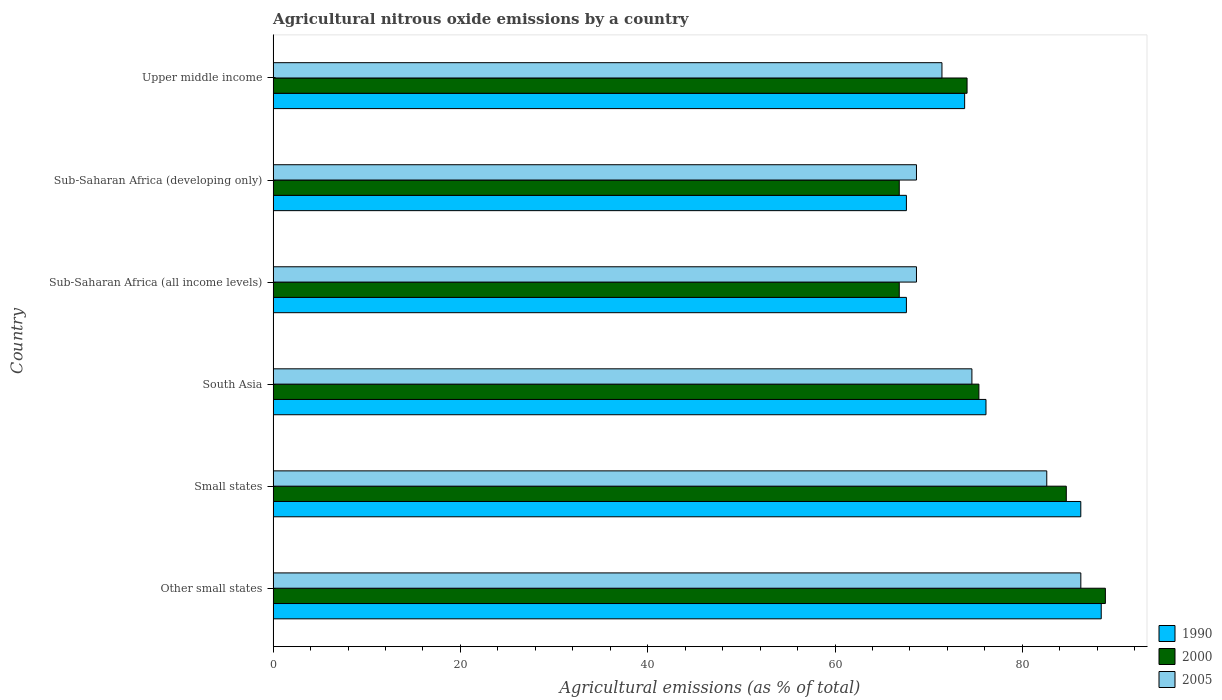How many different coloured bars are there?
Provide a succinct answer. 3. Are the number of bars per tick equal to the number of legend labels?
Your answer should be compact. Yes. How many bars are there on the 4th tick from the bottom?
Your answer should be very brief. 3. What is the label of the 2nd group of bars from the top?
Your response must be concise. Sub-Saharan Africa (developing only). In how many cases, is the number of bars for a given country not equal to the number of legend labels?
Ensure brevity in your answer.  0. What is the amount of agricultural nitrous oxide emitted in 1990 in Sub-Saharan Africa (all income levels)?
Keep it short and to the point. 67.62. Across all countries, what is the maximum amount of agricultural nitrous oxide emitted in 1990?
Keep it short and to the point. 88.42. Across all countries, what is the minimum amount of agricultural nitrous oxide emitted in 2005?
Your answer should be compact. 68.7. In which country was the amount of agricultural nitrous oxide emitted in 1990 maximum?
Ensure brevity in your answer.  Other small states. In which country was the amount of agricultural nitrous oxide emitted in 2000 minimum?
Keep it short and to the point. Sub-Saharan Africa (all income levels). What is the total amount of agricultural nitrous oxide emitted in 2005 in the graph?
Ensure brevity in your answer.  452.28. What is the difference between the amount of agricultural nitrous oxide emitted in 1990 in Other small states and that in Sub-Saharan Africa (developing only)?
Give a very brief answer. 20.8. What is the difference between the amount of agricultural nitrous oxide emitted in 2005 in Upper middle income and the amount of agricultural nitrous oxide emitted in 2000 in Small states?
Provide a succinct answer. -13.28. What is the average amount of agricultural nitrous oxide emitted in 2000 per country?
Make the answer very short. 76.12. What is the difference between the amount of agricultural nitrous oxide emitted in 1990 and amount of agricultural nitrous oxide emitted in 2000 in Sub-Saharan Africa (developing only)?
Your answer should be compact. 0.76. In how many countries, is the amount of agricultural nitrous oxide emitted in 1990 greater than 64 %?
Make the answer very short. 6. What is the ratio of the amount of agricultural nitrous oxide emitted in 2005 in South Asia to that in Sub-Saharan Africa (all income levels)?
Provide a short and direct response. 1.09. Is the amount of agricultural nitrous oxide emitted in 2005 in South Asia less than that in Sub-Saharan Africa (all income levels)?
Make the answer very short. No. Is the difference between the amount of agricultural nitrous oxide emitted in 1990 in Small states and Sub-Saharan Africa (all income levels) greater than the difference between the amount of agricultural nitrous oxide emitted in 2000 in Small states and Sub-Saharan Africa (all income levels)?
Keep it short and to the point. Yes. What is the difference between the highest and the second highest amount of agricultural nitrous oxide emitted in 1990?
Make the answer very short. 2.18. What is the difference between the highest and the lowest amount of agricultural nitrous oxide emitted in 2005?
Your answer should be very brief. 17.55. In how many countries, is the amount of agricultural nitrous oxide emitted in 2000 greater than the average amount of agricultural nitrous oxide emitted in 2000 taken over all countries?
Your answer should be compact. 2. How many countries are there in the graph?
Provide a short and direct response. 6. Are the values on the major ticks of X-axis written in scientific E-notation?
Your answer should be very brief. No. Where does the legend appear in the graph?
Keep it short and to the point. Bottom right. How many legend labels are there?
Your answer should be compact. 3. What is the title of the graph?
Give a very brief answer. Agricultural nitrous oxide emissions by a country. What is the label or title of the X-axis?
Offer a very short reply. Agricultural emissions (as % of total). What is the label or title of the Y-axis?
Offer a terse response. Country. What is the Agricultural emissions (as % of total) of 1990 in Other small states?
Ensure brevity in your answer.  88.42. What is the Agricultural emissions (as % of total) in 2000 in Other small states?
Provide a succinct answer. 88.87. What is the Agricultural emissions (as % of total) in 2005 in Other small states?
Your answer should be very brief. 86.25. What is the Agricultural emissions (as % of total) in 1990 in Small states?
Provide a succinct answer. 86.24. What is the Agricultural emissions (as % of total) in 2000 in Small states?
Your answer should be very brief. 84.69. What is the Agricultural emissions (as % of total) in 2005 in Small states?
Offer a very short reply. 82.61. What is the Agricultural emissions (as % of total) of 1990 in South Asia?
Your answer should be compact. 76.12. What is the Agricultural emissions (as % of total) in 2000 in South Asia?
Keep it short and to the point. 75.36. What is the Agricultural emissions (as % of total) in 2005 in South Asia?
Make the answer very short. 74.62. What is the Agricultural emissions (as % of total) in 1990 in Sub-Saharan Africa (all income levels)?
Offer a very short reply. 67.62. What is the Agricultural emissions (as % of total) of 2000 in Sub-Saharan Africa (all income levels)?
Offer a very short reply. 66.86. What is the Agricultural emissions (as % of total) of 2005 in Sub-Saharan Africa (all income levels)?
Keep it short and to the point. 68.7. What is the Agricultural emissions (as % of total) of 1990 in Sub-Saharan Africa (developing only)?
Your response must be concise. 67.62. What is the Agricultural emissions (as % of total) of 2000 in Sub-Saharan Africa (developing only)?
Ensure brevity in your answer.  66.86. What is the Agricultural emissions (as % of total) in 2005 in Sub-Saharan Africa (developing only)?
Provide a short and direct response. 68.7. What is the Agricultural emissions (as % of total) of 1990 in Upper middle income?
Offer a terse response. 73.84. What is the Agricultural emissions (as % of total) of 2000 in Upper middle income?
Provide a short and direct response. 74.1. What is the Agricultural emissions (as % of total) of 2005 in Upper middle income?
Your answer should be compact. 71.42. Across all countries, what is the maximum Agricultural emissions (as % of total) of 1990?
Your response must be concise. 88.42. Across all countries, what is the maximum Agricultural emissions (as % of total) of 2000?
Offer a terse response. 88.87. Across all countries, what is the maximum Agricultural emissions (as % of total) of 2005?
Give a very brief answer. 86.25. Across all countries, what is the minimum Agricultural emissions (as % of total) in 1990?
Keep it short and to the point. 67.62. Across all countries, what is the minimum Agricultural emissions (as % of total) in 2000?
Your response must be concise. 66.86. Across all countries, what is the minimum Agricultural emissions (as % of total) in 2005?
Your answer should be very brief. 68.7. What is the total Agricultural emissions (as % of total) in 1990 in the graph?
Give a very brief answer. 459.87. What is the total Agricultural emissions (as % of total) of 2000 in the graph?
Your response must be concise. 456.74. What is the total Agricultural emissions (as % of total) of 2005 in the graph?
Make the answer very short. 452.28. What is the difference between the Agricultural emissions (as % of total) of 1990 in Other small states and that in Small states?
Your response must be concise. 2.18. What is the difference between the Agricultural emissions (as % of total) in 2000 in Other small states and that in Small states?
Your response must be concise. 4.17. What is the difference between the Agricultural emissions (as % of total) in 2005 in Other small states and that in Small states?
Your answer should be compact. 3.64. What is the difference between the Agricultural emissions (as % of total) in 1990 in Other small states and that in South Asia?
Ensure brevity in your answer.  12.31. What is the difference between the Agricultural emissions (as % of total) in 2000 in Other small states and that in South Asia?
Offer a very short reply. 13.51. What is the difference between the Agricultural emissions (as % of total) in 2005 in Other small states and that in South Asia?
Provide a short and direct response. 11.63. What is the difference between the Agricultural emissions (as % of total) of 1990 in Other small states and that in Sub-Saharan Africa (all income levels)?
Offer a very short reply. 20.8. What is the difference between the Agricultural emissions (as % of total) in 2000 in Other small states and that in Sub-Saharan Africa (all income levels)?
Make the answer very short. 22.01. What is the difference between the Agricultural emissions (as % of total) of 2005 in Other small states and that in Sub-Saharan Africa (all income levels)?
Ensure brevity in your answer.  17.55. What is the difference between the Agricultural emissions (as % of total) of 1990 in Other small states and that in Sub-Saharan Africa (developing only)?
Make the answer very short. 20.8. What is the difference between the Agricultural emissions (as % of total) of 2000 in Other small states and that in Sub-Saharan Africa (developing only)?
Your response must be concise. 22.01. What is the difference between the Agricultural emissions (as % of total) in 2005 in Other small states and that in Sub-Saharan Africa (developing only)?
Make the answer very short. 17.55. What is the difference between the Agricultural emissions (as % of total) in 1990 in Other small states and that in Upper middle income?
Offer a very short reply. 14.59. What is the difference between the Agricultural emissions (as % of total) in 2000 in Other small states and that in Upper middle income?
Ensure brevity in your answer.  14.77. What is the difference between the Agricultural emissions (as % of total) of 2005 in Other small states and that in Upper middle income?
Offer a very short reply. 14.83. What is the difference between the Agricultural emissions (as % of total) in 1990 in Small states and that in South Asia?
Your answer should be compact. 10.12. What is the difference between the Agricultural emissions (as % of total) of 2000 in Small states and that in South Asia?
Ensure brevity in your answer.  9.33. What is the difference between the Agricultural emissions (as % of total) in 2005 in Small states and that in South Asia?
Offer a very short reply. 7.99. What is the difference between the Agricultural emissions (as % of total) in 1990 in Small states and that in Sub-Saharan Africa (all income levels)?
Your response must be concise. 18.62. What is the difference between the Agricultural emissions (as % of total) in 2000 in Small states and that in Sub-Saharan Africa (all income levels)?
Ensure brevity in your answer.  17.84. What is the difference between the Agricultural emissions (as % of total) in 2005 in Small states and that in Sub-Saharan Africa (all income levels)?
Your response must be concise. 13.91. What is the difference between the Agricultural emissions (as % of total) of 1990 in Small states and that in Sub-Saharan Africa (developing only)?
Provide a succinct answer. 18.62. What is the difference between the Agricultural emissions (as % of total) of 2000 in Small states and that in Sub-Saharan Africa (developing only)?
Make the answer very short. 17.84. What is the difference between the Agricultural emissions (as % of total) of 2005 in Small states and that in Sub-Saharan Africa (developing only)?
Your answer should be compact. 13.91. What is the difference between the Agricultural emissions (as % of total) of 1990 in Small states and that in Upper middle income?
Keep it short and to the point. 12.4. What is the difference between the Agricultural emissions (as % of total) in 2000 in Small states and that in Upper middle income?
Make the answer very short. 10.6. What is the difference between the Agricultural emissions (as % of total) of 2005 in Small states and that in Upper middle income?
Give a very brief answer. 11.19. What is the difference between the Agricultural emissions (as % of total) in 1990 in South Asia and that in Sub-Saharan Africa (all income levels)?
Ensure brevity in your answer.  8.5. What is the difference between the Agricultural emissions (as % of total) of 2000 in South Asia and that in Sub-Saharan Africa (all income levels)?
Keep it short and to the point. 8.5. What is the difference between the Agricultural emissions (as % of total) of 2005 in South Asia and that in Sub-Saharan Africa (all income levels)?
Provide a succinct answer. 5.92. What is the difference between the Agricultural emissions (as % of total) in 1990 in South Asia and that in Sub-Saharan Africa (developing only)?
Your answer should be compact. 8.5. What is the difference between the Agricultural emissions (as % of total) of 2000 in South Asia and that in Sub-Saharan Africa (developing only)?
Your response must be concise. 8.5. What is the difference between the Agricultural emissions (as % of total) of 2005 in South Asia and that in Sub-Saharan Africa (developing only)?
Ensure brevity in your answer.  5.92. What is the difference between the Agricultural emissions (as % of total) in 1990 in South Asia and that in Upper middle income?
Give a very brief answer. 2.28. What is the difference between the Agricultural emissions (as % of total) in 2000 in South Asia and that in Upper middle income?
Your response must be concise. 1.26. What is the difference between the Agricultural emissions (as % of total) in 2005 in South Asia and that in Upper middle income?
Offer a terse response. 3.2. What is the difference between the Agricultural emissions (as % of total) in 1990 in Sub-Saharan Africa (all income levels) and that in Sub-Saharan Africa (developing only)?
Your response must be concise. 0. What is the difference between the Agricultural emissions (as % of total) of 2000 in Sub-Saharan Africa (all income levels) and that in Sub-Saharan Africa (developing only)?
Ensure brevity in your answer.  0. What is the difference between the Agricultural emissions (as % of total) in 1990 in Sub-Saharan Africa (all income levels) and that in Upper middle income?
Give a very brief answer. -6.22. What is the difference between the Agricultural emissions (as % of total) in 2000 in Sub-Saharan Africa (all income levels) and that in Upper middle income?
Offer a terse response. -7.24. What is the difference between the Agricultural emissions (as % of total) in 2005 in Sub-Saharan Africa (all income levels) and that in Upper middle income?
Ensure brevity in your answer.  -2.72. What is the difference between the Agricultural emissions (as % of total) in 1990 in Sub-Saharan Africa (developing only) and that in Upper middle income?
Give a very brief answer. -6.22. What is the difference between the Agricultural emissions (as % of total) in 2000 in Sub-Saharan Africa (developing only) and that in Upper middle income?
Keep it short and to the point. -7.24. What is the difference between the Agricultural emissions (as % of total) of 2005 in Sub-Saharan Africa (developing only) and that in Upper middle income?
Your answer should be compact. -2.72. What is the difference between the Agricultural emissions (as % of total) in 1990 in Other small states and the Agricultural emissions (as % of total) in 2000 in Small states?
Offer a very short reply. 3.73. What is the difference between the Agricultural emissions (as % of total) in 1990 in Other small states and the Agricultural emissions (as % of total) in 2005 in Small states?
Your response must be concise. 5.82. What is the difference between the Agricultural emissions (as % of total) of 2000 in Other small states and the Agricultural emissions (as % of total) of 2005 in Small states?
Your response must be concise. 6.26. What is the difference between the Agricultural emissions (as % of total) of 1990 in Other small states and the Agricultural emissions (as % of total) of 2000 in South Asia?
Make the answer very short. 13.06. What is the difference between the Agricultural emissions (as % of total) in 1990 in Other small states and the Agricultural emissions (as % of total) in 2005 in South Asia?
Provide a succinct answer. 13.81. What is the difference between the Agricultural emissions (as % of total) in 2000 in Other small states and the Agricultural emissions (as % of total) in 2005 in South Asia?
Your response must be concise. 14.25. What is the difference between the Agricultural emissions (as % of total) of 1990 in Other small states and the Agricultural emissions (as % of total) of 2000 in Sub-Saharan Africa (all income levels)?
Give a very brief answer. 21.57. What is the difference between the Agricultural emissions (as % of total) in 1990 in Other small states and the Agricultural emissions (as % of total) in 2005 in Sub-Saharan Africa (all income levels)?
Provide a short and direct response. 19.73. What is the difference between the Agricultural emissions (as % of total) in 2000 in Other small states and the Agricultural emissions (as % of total) in 2005 in Sub-Saharan Africa (all income levels)?
Your answer should be compact. 20.17. What is the difference between the Agricultural emissions (as % of total) in 1990 in Other small states and the Agricultural emissions (as % of total) in 2000 in Sub-Saharan Africa (developing only)?
Your answer should be very brief. 21.57. What is the difference between the Agricultural emissions (as % of total) in 1990 in Other small states and the Agricultural emissions (as % of total) in 2005 in Sub-Saharan Africa (developing only)?
Offer a very short reply. 19.73. What is the difference between the Agricultural emissions (as % of total) of 2000 in Other small states and the Agricultural emissions (as % of total) of 2005 in Sub-Saharan Africa (developing only)?
Your answer should be very brief. 20.17. What is the difference between the Agricultural emissions (as % of total) of 1990 in Other small states and the Agricultural emissions (as % of total) of 2000 in Upper middle income?
Provide a succinct answer. 14.33. What is the difference between the Agricultural emissions (as % of total) in 1990 in Other small states and the Agricultural emissions (as % of total) in 2005 in Upper middle income?
Ensure brevity in your answer.  17.01. What is the difference between the Agricultural emissions (as % of total) of 2000 in Other small states and the Agricultural emissions (as % of total) of 2005 in Upper middle income?
Keep it short and to the point. 17.45. What is the difference between the Agricultural emissions (as % of total) of 1990 in Small states and the Agricultural emissions (as % of total) of 2000 in South Asia?
Your response must be concise. 10.88. What is the difference between the Agricultural emissions (as % of total) in 1990 in Small states and the Agricultural emissions (as % of total) in 2005 in South Asia?
Offer a terse response. 11.63. What is the difference between the Agricultural emissions (as % of total) in 2000 in Small states and the Agricultural emissions (as % of total) in 2005 in South Asia?
Provide a short and direct response. 10.08. What is the difference between the Agricultural emissions (as % of total) in 1990 in Small states and the Agricultural emissions (as % of total) in 2000 in Sub-Saharan Africa (all income levels)?
Provide a succinct answer. 19.39. What is the difference between the Agricultural emissions (as % of total) in 1990 in Small states and the Agricultural emissions (as % of total) in 2005 in Sub-Saharan Africa (all income levels)?
Give a very brief answer. 17.55. What is the difference between the Agricultural emissions (as % of total) of 2000 in Small states and the Agricultural emissions (as % of total) of 2005 in Sub-Saharan Africa (all income levels)?
Ensure brevity in your answer.  16. What is the difference between the Agricultural emissions (as % of total) of 1990 in Small states and the Agricultural emissions (as % of total) of 2000 in Sub-Saharan Africa (developing only)?
Ensure brevity in your answer.  19.39. What is the difference between the Agricultural emissions (as % of total) in 1990 in Small states and the Agricultural emissions (as % of total) in 2005 in Sub-Saharan Africa (developing only)?
Provide a succinct answer. 17.55. What is the difference between the Agricultural emissions (as % of total) in 2000 in Small states and the Agricultural emissions (as % of total) in 2005 in Sub-Saharan Africa (developing only)?
Your answer should be compact. 16. What is the difference between the Agricultural emissions (as % of total) in 1990 in Small states and the Agricultural emissions (as % of total) in 2000 in Upper middle income?
Your answer should be very brief. 12.14. What is the difference between the Agricultural emissions (as % of total) of 1990 in Small states and the Agricultural emissions (as % of total) of 2005 in Upper middle income?
Your answer should be very brief. 14.83. What is the difference between the Agricultural emissions (as % of total) in 2000 in Small states and the Agricultural emissions (as % of total) in 2005 in Upper middle income?
Provide a short and direct response. 13.28. What is the difference between the Agricultural emissions (as % of total) in 1990 in South Asia and the Agricultural emissions (as % of total) in 2000 in Sub-Saharan Africa (all income levels)?
Offer a very short reply. 9.26. What is the difference between the Agricultural emissions (as % of total) in 1990 in South Asia and the Agricultural emissions (as % of total) in 2005 in Sub-Saharan Africa (all income levels)?
Provide a short and direct response. 7.42. What is the difference between the Agricultural emissions (as % of total) in 2000 in South Asia and the Agricultural emissions (as % of total) in 2005 in Sub-Saharan Africa (all income levels)?
Your answer should be very brief. 6.67. What is the difference between the Agricultural emissions (as % of total) of 1990 in South Asia and the Agricultural emissions (as % of total) of 2000 in Sub-Saharan Africa (developing only)?
Provide a short and direct response. 9.26. What is the difference between the Agricultural emissions (as % of total) in 1990 in South Asia and the Agricultural emissions (as % of total) in 2005 in Sub-Saharan Africa (developing only)?
Your answer should be very brief. 7.42. What is the difference between the Agricultural emissions (as % of total) in 2000 in South Asia and the Agricultural emissions (as % of total) in 2005 in Sub-Saharan Africa (developing only)?
Your answer should be very brief. 6.67. What is the difference between the Agricultural emissions (as % of total) in 1990 in South Asia and the Agricultural emissions (as % of total) in 2000 in Upper middle income?
Provide a succinct answer. 2.02. What is the difference between the Agricultural emissions (as % of total) of 1990 in South Asia and the Agricultural emissions (as % of total) of 2005 in Upper middle income?
Your response must be concise. 4.7. What is the difference between the Agricultural emissions (as % of total) in 2000 in South Asia and the Agricultural emissions (as % of total) in 2005 in Upper middle income?
Make the answer very short. 3.95. What is the difference between the Agricultural emissions (as % of total) in 1990 in Sub-Saharan Africa (all income levels) and the Agricultural emissions (as % of total) in 2000 in Sub-Saharan Africa (developing only)?
Your answer should be very brief. 0.76. What is the difference between the Agricultural emissions (as % of total) of 1990 in Sub-Saharan Africa (all income levels) and the Agricultural emissions (as % of total) of 2005 in Sub-Saharan Africa (developing only)?
Offer a very short reply. -1.08. What is the difference between the Agricultural emissions (as % of total) in 2000 in Sub-Saharan Africa (all income levels) and the Agricultural emissions (as % of total) in 2005 in Sub-Saharan Africa (developing only)?
Make the answer very short. -1.84. What is the difference between the Agricultural emissions (as % of total) in 1990 in Sub-Saharan Africa (all income levels) and the Agricultural emissions (as % of total) in 2000 in Upper middle income?
Your response must be concise. -6.48. What is the difference between the Agricultural emissions (as % of total) in 1990 in Sub-Saharan Africa (all income levels) and the Agricultural emissions (as % of total) in 2005 in Upper middle income?
Your answer should be compact. -3.8. What is the difference between the Agricultural emissions (as % of total) of 2000 in Sub-Saharan Africa (all income levels) and the Agricultural emissions (as % of total) of 2005 in Upper middle income?
Provide a succinct answer. -4.56. What is the difference between the Agricultural emissions (as % of total) of 1990 in Sub-Saharan Africa (developing only) and the Agricultural emissions (as % of total) of 2000 in Upper middle income?
Your answer should be very brief. -6.48. What is the difference between the Agricultural emissions (as % of total) of 1990 in Sub-Saharan Africa (developing only) and the Agricultural emissions (as % of total) of 2005 in Upper middle income?
Keep it short and to the point. -3.8. What is the difference between the Agricultural emissions (as % of total) in 2000 in Sub-Saharan Africa (developing only) and the Agricultural emissions (as % of total) in 2005 in Upper middle income?
Your answer should be very brief. -4.56. What is the average Agricultural emissions (as % of total) of 1990 per country?
Your answer should be compact. 76.64. What is the average Agricultural emissions (as % of total) of 2000 per country?
Ensure brevity in your answer.  76.12. What is the average Agricultural emissions (as % of total) in 2005 per country?
Provide a succinct answer. 75.38. What is the difference between the Agricultural emissions (as % of total) in 1990 and Agricultural emissions (as % of total) in 2000 in Other small states?
Make the answer very short. -0.44. What is the difference between the Agricultural emissions (as % of total) in 1990 and Agricultural emissions (as % of total) in 2005 in Other small states?
Provide a short and direct response. 2.18. What is the difference between the Agricultural emissions (as % of total) in 2000 and Agricultural emissions (as % of total) in 2005 in Other small states?
Offer a terse response. 2.62. What is the difference between the Agricultural emissions (as % of total) of 1990 and Agricultural emissions (as % of total) of 2000 in Small states?
Your answer should be compact. 1.55. What is the difference between the Agricultural emissions (as % of total) of 1990 and Agricultural emissions (as % of total) of 2005 in Small states?
Provide a short and direct response. 3.64. What is the difference between the Agricultural emissions (as % of total) of 2000 and Agricultural emissions (as % of total) of 2005 in Small states?
Make the answer very short. 2.09. What is the difference between the Agricultural emissions (as % of total) in 1990 and Agricultural emissions (as % of total) in 2000 in South Asia?
Make the answer very short. 0.76. What is the difference between the Agricultural emissions (as % of total) in 1990 and Agricultural emissions (as % of total) in 2005 in South Asia?
Provide a succinct answer. 1.5. What is the difference between the Agricultural emissions (as % of total) of 2000 and Agricultural emissions (as % of total) of 2005 in South Asia?
Your answer should be very brief. 0.75. What is the difference between the Agricultural emissions (as % of total) of 1990 and Agricultural emissions (as % of total) of 2000 in Sub-Saharan Africa (all income levels)?
Give a very brief answer. 0.76. What is the difference between the Agricultural emissions (as % of total) of 1990 and Agricultural emissions (as % of total) of 2005 in Sub-Saharan Africa (all income levels)?
Keep it short and to the point. -1.08. What is the difference between the Agricultural emissions (as % of total) of 2000 and Agricultural emissions (as % of total) of 2005 in Sub-Saharan Africa (all income levels)?
Provide a short and direct response. -1.84. What is the difference between the Agricultural emissions (as % of total) in 1990 and Agricultural emissions (as % of total) in 2000 in Sub-Saharan Africa (developing only)?
Ensure brevity in your answer.  0.76. What is the difference between the Agricultural emissions (as % of total) of 1990 and Agricultural emissions (as % of total) of 2005 in Sub-Saharan Africa (developing only)?
Ensure brevity in your answer.  -1.08. What is the difference between the Agricultural emissions (as % of total) in 2000 and Agricultural emissions (as % of total) in 2005 in Sub-Saharan Africa (developing only)?
Make the answer very short. -1.84. What is the difference between the Agricultural emissions (as % of total) of 1990 and Agricultural emissions (as % of total) of 2000 in Upper middle income?
Provide a short and direct response. -0.26. What is the difference between the Agricultural emissions (as % of total) in 1990 and Agricultural emissions (as % of total) in 2005 in Upper middle income?
Your response must be concise. 2.42. What is the difference between the Agricultural emissions (as % of total) in 2000 and Agricultural emissions (as % of total) in 2005 in Upper middle income?
Your answer should be compact. 2.68. What is the ratio of the Agricultural emissions (as % of total) of 1990 in Other small states to that in Small states?
Your answer should be very brief. 1.03. What is the ratio of the Agricultural emissions (as % of total) in 2000 in Other small states to that in Small states?
Provide a succinct answer. 1.05. What is the ratio of the Agricultural emissions (as % of total) of 2005 in Other small states to that in Small states?
Offer a terse response. 1.04. What is the ratio of the Agricultural emissions (as % of total) of 1990 in Other small states to that in South Asia?
Provide a succinct answer. 1.16. What is the ratio of the Agricultural emissions (as % of total) in 2000 in Other small states to that in South Asia?
Keep it short and to the point. 1.18. What is the ratio of the Agricultural emissions (as % of total) in 2005 in Other small states to that in South Asia?
Give a very brief answer. 1.16. What is the ratio of the Agricultural emissions (as % of total) of 1990 in Other small states to that in Sub-Saharan Africa (all income levels)?
Give a very brief answer. 1.31. What is the ratio of the Agricultural emissions (as % of total) in 2000 in Other small states to that in Sub-Saharan Africa (all income levels)?
Offer a very short reply. 1.33. What is the ratio of the Agricultural emissions (as % of total) of 2005 in Other small states to that in Sub-Saharan Africa (all income levels)?
Keep it short and to the point. 1.26. What is the ratio of the Agricultural emissions (as % of total) of 1990 in Other small states to that in Sub-Saharan Africa (developing only)?
Your answer should be very brief. 1.31. What is the ratio of the Agricultural emissions (as % of total) of 2000 in Other small states to that in Sub-Saharan Africa (developing only)?
Provide a short and direct response. 1.33. What is the ratio of the Agricultural emissions (as % of total) in 2005 in Other small states to that in Sub-Saharan Africa (developing only)?
Keep it short and to the point. 1.26. What is the ratio of the Agricultural emissions (as % of total) of 1990 in Other small states to that in Upper middle income?
Offer a very short reply. 1.2. What is the ratio of the Agricultural emissions (as % of total) in 2000 in Other small states to that in Upper middle income?
Provide a succinct answer. 1.2. What is the ratio of the Agricultural emissions (as % of total) in 2005 in Other small states to that in Upper middle income?
Provide a short and direct response. 1.21. What is the ratio of the Agricultural emissions (as % of total) in 1990 in Small states to that in South Asia?
Make the answer very short. 1.13. What is the ratio of the Agricultural emissions (as % of total) in 2000 in Small states to that in South Asia?
Offer a very short reply. 1.12. What is the ratio of the Agricultural emissions (as % of total) in 2005 in Small states to that in South Asia?
Provide a short and direct response. 1.11. What is the ratio of the Agricultural emissions (as % of total) in 1990 in Small states to that in Sub-Saharan Africa (all income levels)?
Provide a short and direct response. 1.28. What is the ratio of the Agricultural emissions (as % of total) of 2000 in Small states to that in Sub-Saharan Africa (all income levels)?
Offer a very short reply. 1.27. What is the ratio of the Agricultural emissions (as % of total) of 2005 in Small states to that in Sub-Saharan Africa (all income levels)?
Give a very brief answer. 1.2. What is the ratio of the Agricultural emissions (as % of total) in 1990 in Small states to that in Sub-Saharan Africa (developing only)?
Your answer should be compact. 1.28. What is the ratio of the Agricultural emissions (as % of total) of 2000 in Small states to that in Sub-Saharan Africa (developing only)?
Provide a succinct answer. 1.27. What is the ratio of the Agricultural emissions (as % of total) in 2005 in Small states to that in Sub-Saharan Africa (developing only)?
Provide a short and direct response. 1.2. What is the ratio of the Agricultural emissions (as % of total) of 1990 in Small states to that in Upper middle income?
Your answer should be very brief. 1.17. What is the ratio of the Agricultural emissions (as % of total) of 2000 in Small states to that in Upper middle income?
Provide a succinct answer. 1.14. What is the ratio of the Agricultural emissions (as % of total) in 2005 in Small states to that in Upper middle income?
Ensure brevity in your answer.  1.16. What is the ratio of the Agricultural emissions (as % of total) of 1990 in South Asia to that in Sub-Saharan Africa (all income levels)?
Offer a very short reply. 1.13. What is the ratio of the Agricultural emissions (as % of total) of 2000 in South Asia to that in Sub-Saharan Africa (all income levels)?
Offer a terse response. 1.13. What is the ratio of the Agricultural emissions (as % of total) in 2005 in South Asia to that in Sub-Saharan Africa (all income levels)?
Your answer should be very brief. 1.09. What is the ratio of the Agricultural emissions (as % of total) of 1990 in South Asia to that in Sub-Saharan Africa (developing only)?
Offer a very short reply. 1.13. What is the ratio of the Agricultural emissions (as % of total) of 2000 in South Asia to that in Sub-Saharan Africa (developing only)?
Your response must be concise. 1.13. What is the ratio of the Agricultural emissions (as % of total) of 2005 in South Asia to that in Sub-Saharan Africa (developing only)?
Provide a succinct answer. 1.09. What is the ratio of the Agricultural emissions (as % of total) in 1990 in South Asia to that in Upper middle income?
Offer a very short reply. 1.03. What is the ratio of the Agricultural emissions (as % of total) of 2005 in South Asia to that in Upper middle income?
Make the answer very short. 1.04. What is the ratio of the Agricultural emissions (as % of total) of 1990 in Sub-Saharan Africa (all income levels) to that in Sub-Saharan Africa (developing only)?
Keep it short and to the point. 1. What is the ratio of the Agricultural emissions (as % of total) of 1990 in Sub-Saharan Africa (all income levels) to that in Upper middle income?
Your answer should be very brief. 0.92. What is the ratio of the Agricultural emissions (as % of total) in 2000 in Sub-Saharan Africa (all income levels) to that in Upper middle income?
Make the answer very short. 0.9. What is the ratio of the Agricultural emissions (as % of total) of 2005 in Sub-Saharan Africa (all income levels) to that in Upper middle income?
Offer a very short reply. 0.96. What is the ratio of the Agricultural emissions (as % of total) in 1990 in Sub-Saharan Africa (developing only) to that in Upper middle income?
Make the answer very short. 0.92. What is the ratio of the Agricultural emissions (as % of total) in 2000 in Sub-Saharan Africa (developing only) to that in Upper middle income?
Your response must be concise. 0.9. What is the ratio of the Agricultural emissions (as % of total) of 2005 in Sub-Saharan Africa (developing only) to that in Upper middle income?
Provide a succinct answer. 0.96. What is the difference between the highest and the second highest Agricultural emissions (as % of total) in 1990?
Provide a short and direct response. 2.18. What is the difference between the highest and the second highest Agricultural emissions (as % of total) in 2000?
Offer a terse response. 4.17. What is the difference between the highest and the second highest Agricultural emissions (as % of total) in 2005?
Ensure brevity in your answer.  3.64. What is the difference between the highest and the lowest Agricultural emissions (as % of total) in 1990?
Your answer should be very brief. 20.8. What is the difference between the highest and the lowest Agricultural emissions (as % of total) in 2000?
Provide a succinct answer. 22.01. What is the difference between the highest and the lowest Agricultural emissions (as % of total) in 2005?
Keep it short and to the point. 17.55. 